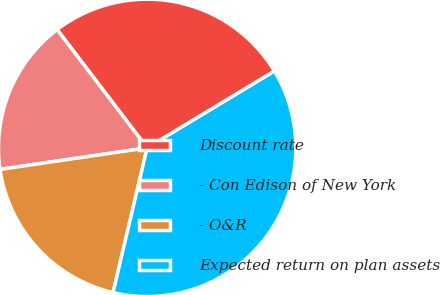<chart> <loc_0><loc_0><loc_500><loc_500><pie_chart><fcel>Discount rate<fcel>- Con Edison of New York<fcel>- O&R<fcel>Expected return on plan assets<nl><fcel>26.72%<fcel>16.96%<fcel>19.0%<fcel>37.32%<nl></chart> 